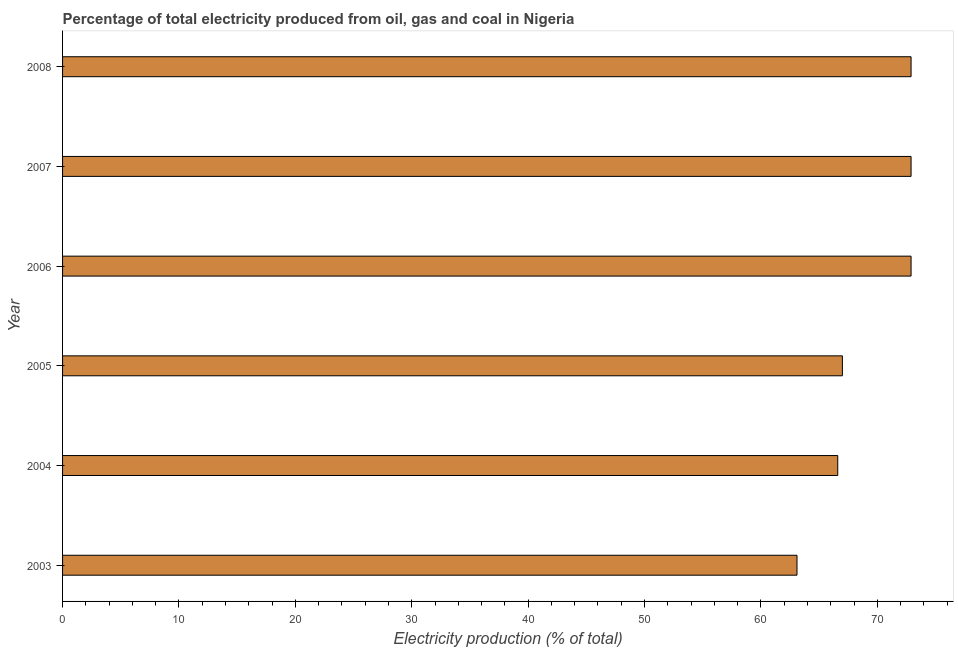What is the title of the graph?
Your answer should be very brief. Percentage of total electricity produced from oil, gas and coal in Nigeria. What is the label or title of the X-axis?
Your response must be concise. Electricity production (% of total). What is the electricity production in 2005?
Provide a short and direct response. 67. Across all years, what is the maximum electricity production?
Your response must be concise. 72.9. Across all years, what is the minimum electricity production?
Your answer should be compact. 63.1. In which year was the electricity production maximum?
Provide a succinct answer. 2007. What is the sum of the electricity production?
Provide a succinct answer. 415.4. What is the difference between the electricity production in 2003 and 2007?
Provide a succinct answer. -9.8. What is the average electricity production per year?
Offer a terse response. 69.23. What is the median electricity production?
Your answer should be very brief. 69.95. In how many years, is the electricity production greater than 18 %?
Offer a very short reply. 6. What is the ratio of the electricity production in 2005 to that in 2007?
Keep it short and to the point. 0.92. Is the electricity production in 2003 less than that in 2005?
Keep it short and to the point. Yes. Is the difference between the electricity production in 2003 and 2004 greater than the difference between any two years?
Ensure brevity in your answer.  No. What is the difference between the highest and the lowest electricity production?
Your answer should be very brief. 9.8. In how many years, is the electricity production greater than the average electricity production taken over all years?
Offer a very short reply. 3. How many bars are there?
Your answer should be compact. 6. What is the Electricity production (% of total) of 2003?
Provide a short and direct response. 63.1. What is the Electricity production (% of total) in 2004?
Your response must be concise. 66.6. What is the Electricity production (% of total) of 2005?
Offer a terse response. 67. What is the Electricity production (% of total) of 2006?
Your response must be concise. 72.9. What is the Electricity production (% of total) in 2007?
Keep it short and to the point. 72.9. What is the Electricity production (% of total) in 2008?
Your answer should be compact. 72.9. What is the difference between the Electricity production (% of total) in 2003 and 2004?
Give a very brief answer. -3.5. What is the difference between the Electricity production (% of total) in 2003 and 2005?
Give a very brief answer. -3.9. What is the difference between the Electricity production (% of total) in 2003 and 2006?
Provide a short and direct response. -9.8. What is the difference between the Electricity production (% of total) in 2003 and 2007?
Keep it short and to the point. -9.8. What is the difference between the Electricity production (% of total) in 2003 and 2008?
Your answer should be compact. -9.8. What is the difference between the Electricity production (% of total) in 2004 and 2005?
Your answer should be very brief. -0.4. What is the difference between the Electricity production (% of total) in 2004 and 2006?
Provide a short and direct response. -6.3. What is the difference between the Electricity production (% of total) in 2004 and 2007?
Ensure brevity in your answer.  -6.3. What is the difference between the Electricity production (% of total) in 2004 and 2008?
Offer a very short reply. -6.3. What is the difference between the Electricity production (% of total) in 2005 and 2006?
Offer a terse response. -5.9. What is the difference between the Electricity production (% of total) in 2005 and 2007?
Offer a very short reply. -5.9. What is the difference between the Electricity production (% of total) in 2005 and 2008?
Make the answer very short. -5.9. What is the difference between the Electricity production (% of total) in 2006 and 2007?
Keep it short and to the point. -0. What is the difference between the Electricity production (% of total) in 2006 and 2008?
Your response must be concise. 8e-5. What is the difference between the Electricity production (% of total) in 2007 and 2008?
Provide a short and direct response. 0. What is the ratio of the Electricity production (% of total) in 2003 to that in 2004?
Provide a succinct answer. 0.95. What is the ratio of the Electricity production (% of total) in 2003 to that in 2005?
Offer a very short reply. 0.94. What is the ratio of the Electricity production (% of total) in 2003 to that in 2006?
Offer a very short reply. 0.87. What is the ratio of the Electricity production (% of total) in 2003 to that in 2007?
Provide a succinct answer. 0.87. What is the ratio of the Electricity production (% of total) in 2003 to that in 2008?
Your response must be concise. 0.87. What is the ratio of the Electricity production (% of total) in 2004 to that in 2006?
Offer a very short reply. 0.91. What is the ratio of the Electricity production (% of total) in 2004 to that in 2007?
Provide a succinct answer. 0.91. What is the ratio of the Electricity production (% of total) in 2004 to that in 2008?
Your answer should be very brief. 0.91. What is the ratio of the Electricity production (% of total) in 2005 to that in 2006?
Make the answer very short. 0.92. What is the ratio of the Electricity production (% of total) in 2005 to that in 2007?
Offer a very short reply. 0.92. What is the ratio of the Electricity production (% of total) in 2005 to that in 2008?
Provide a succinct answer. 0.92. What is the ratio of the Electricity production (% of total) in 2007 to that in 2008?
Offer a very short reply. 1. 